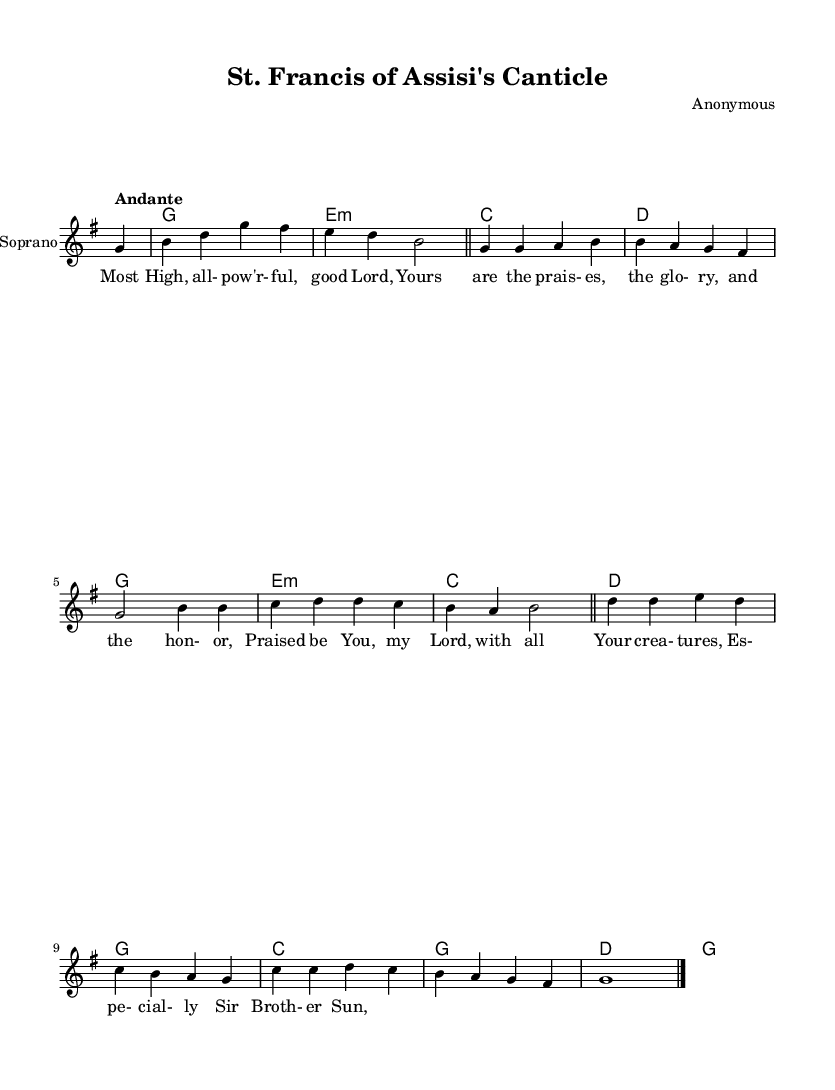What is the key signature of this music? The key signature indicates that this piece is in G major, which has one sharp (F#). This can be identified by looking at the key signature shown at the beginning of the score.
Answer: G major What is the time signature of this music? The time signature, found at the beginning of the score, is 4/4. This means there are four beats per measure.
Answer: 4/4 What is the tempo marking of this music? The tempo marking is indicated as "Andante," which typically means a moderately slow pace. This can be read directly from the tempo indication in the score.
Answer: Andante How many measures does the introduction consist of? The introduction contains 3 measures, as counted from the section before the first verse. Each measure is visually separated by a bar line, and there are three visible before the verse begins.
Answer: 3 What are the main thematic elements of the lyrics? The lyrics celebrate creation and praise God, focused particularly on "Brother Sun," which reflects a common theme in sacred works like those focused on St. Francis. This understanding can be gleaned from the text itself within the music.
Answer: Praise of creation How many distinct parts are there in the structure of this piece? The piece consists of two main parts: the verse and the chorus, as indicated by the structure of the music with clear separations labeled by bar lines. The repetition of musical phrases also supports this division.
Answer: 2 What is the final note in the soprano part? The final note in the soprano part is G, held for a whole note duration, as indicated at the end of the music score. This is noted by observing the last measure in the soprano staff.
Answer: G 